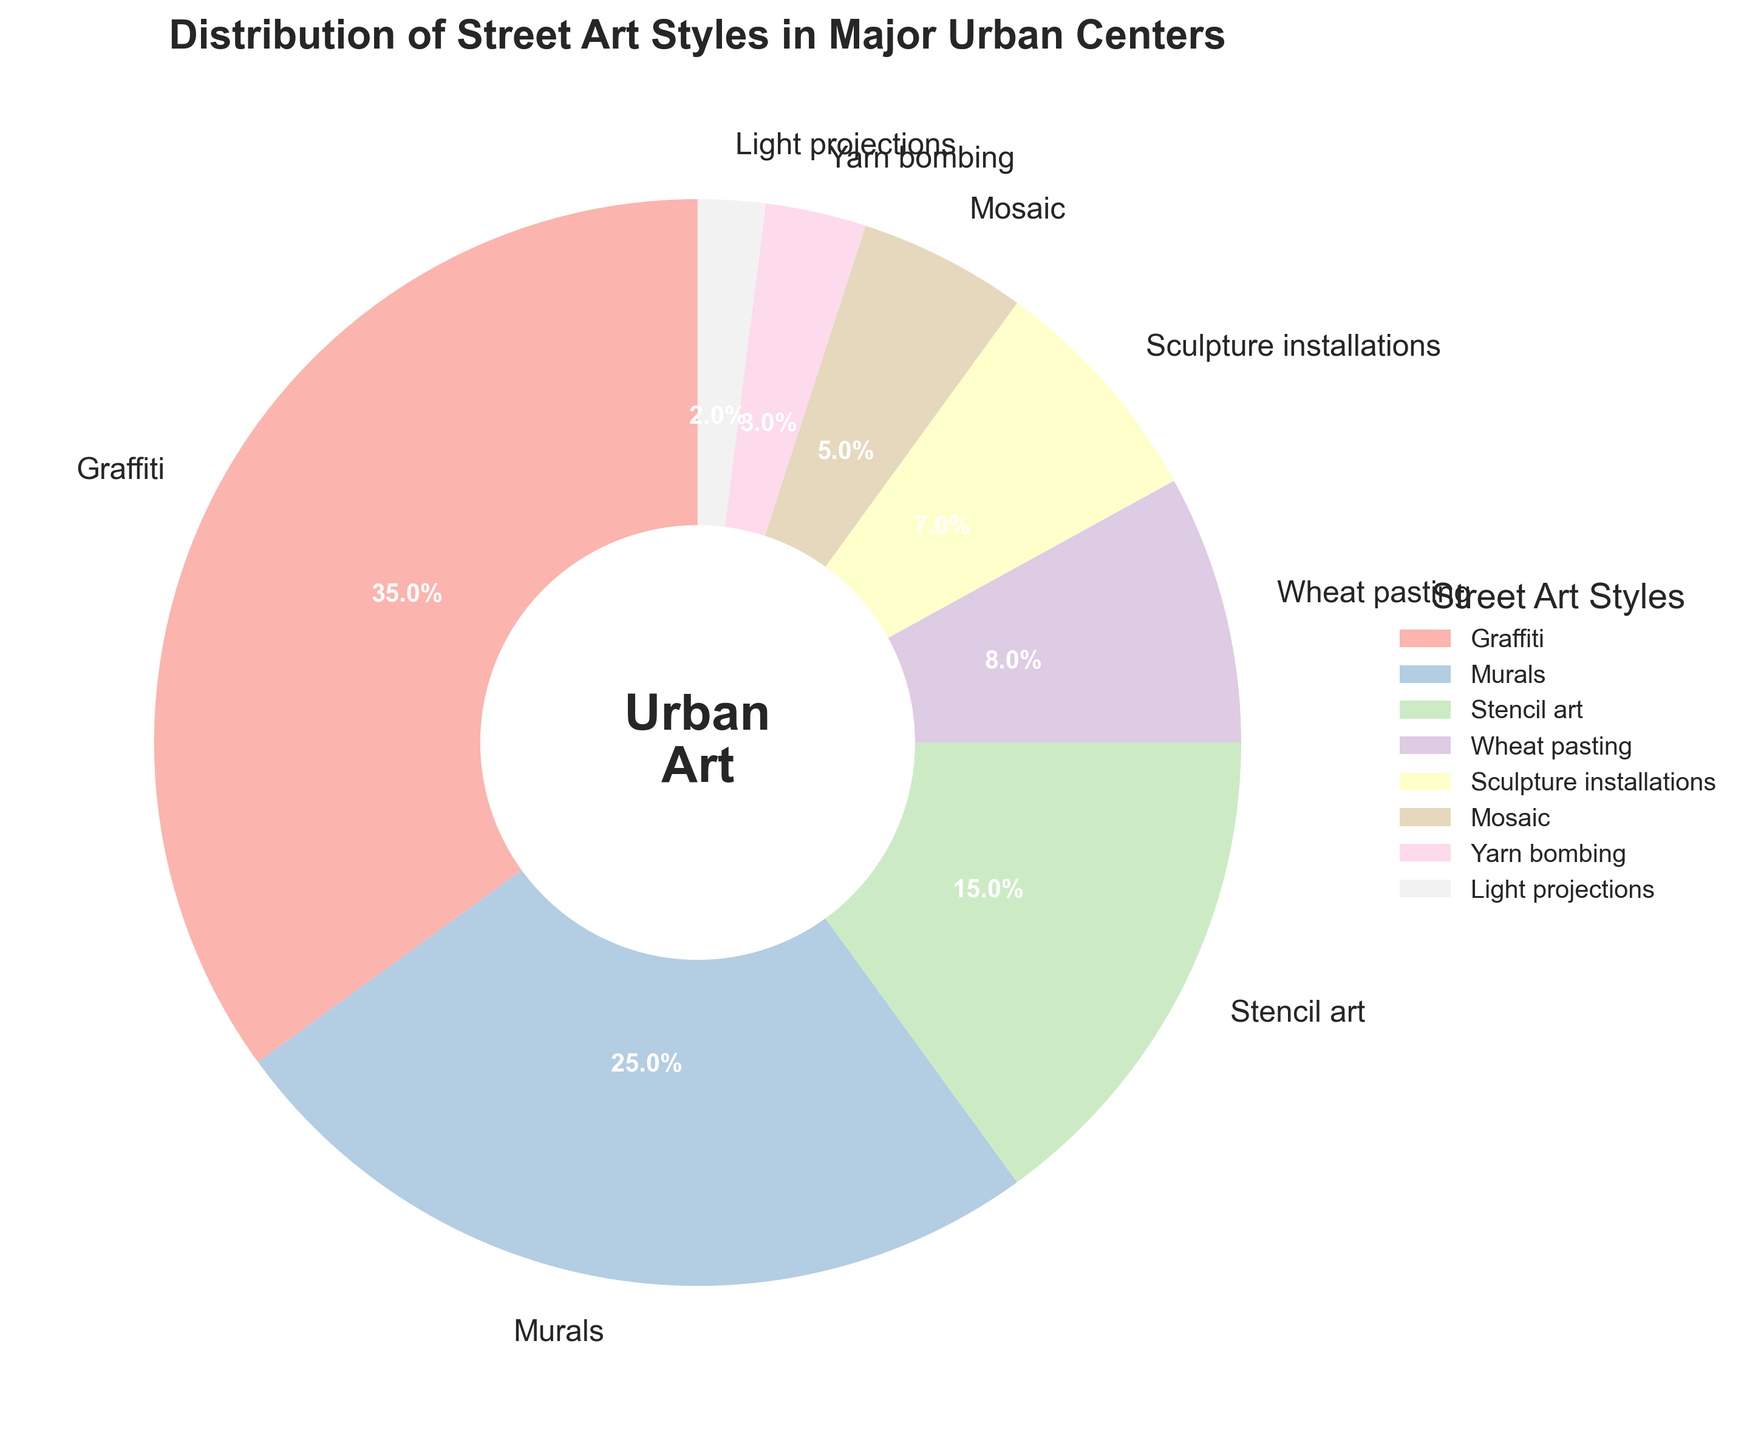What's the most common street art style in major urban centers? The figure shows that Graffiti has the largest segment in the pie chart, indicating it has the highest percentage.
Answer: Graffiti What percentage of street art does Wheat pasting and Sculpture installations together represent? Wheat pasting is 8% and Sculpture installations is 7%. Their sum is 8% + 7% = 15%.
Answer: 15% Which street art style has the smallest representation in major urban centers? Light projections has the smallest wedge in the pie chart, representing 2%.
Answer: Light projections Are there more Murals or Stencil art in major urban centers? The slice for Murals represents 25%, while the slice for Stencil art represents 15%. Since 25% is greater than 15%, there are more Murals.
Answer: Murals What’s the difference in percentage between Graffiti and Murals? The percentage for Graffiti is 35% and for Murals is 25%. The difference is 35% - 25% = 10%.
Answer: 10% What styles collectively make up less than 10% of street art each? Wheat pasting is 8%, Sculpture installations is 7%, Mosaic is 5%, Yarn bombing is 3%, and Light projections is 2%. All of these are less than 10%.
Answer: Wheat pasting, Sculpture installations, Mosaic, Yarn bombing, Light projections How much more common is Mosaic compared to Yarn bombing? Mosaic is 5% and Yarn bombing is 3%. The difference is 5% - 3% = 2%.
Answer: 2% Which pair of styles has a combined percentage closest to 50%? Graffiti and Murals together sum to 35% + 25% = 60%. Graffiti and Stencil art sum to 35% + 15% = 50%. Murals and Stencil art sum to 25% + 15% = 40%. The closest combination to 50% is Graffiti and Stencil art.
Answer: Graffiti and Stencil art What is the average percentage of all listed street art styles? To find the average, sum all the percentages: 35% + 25% + 15% + 8% + 7% + 5% + 3% + 2% = 100%. Divide by the number of styles, which is 8. So, the average is 100% / 8 = 12.5%.
Answer: 12.5% What is the second least common street art style? The least common style is Light projections at 2%. The second least common style is Yarn bombing at 3%.
Answer: Yarn bombing 